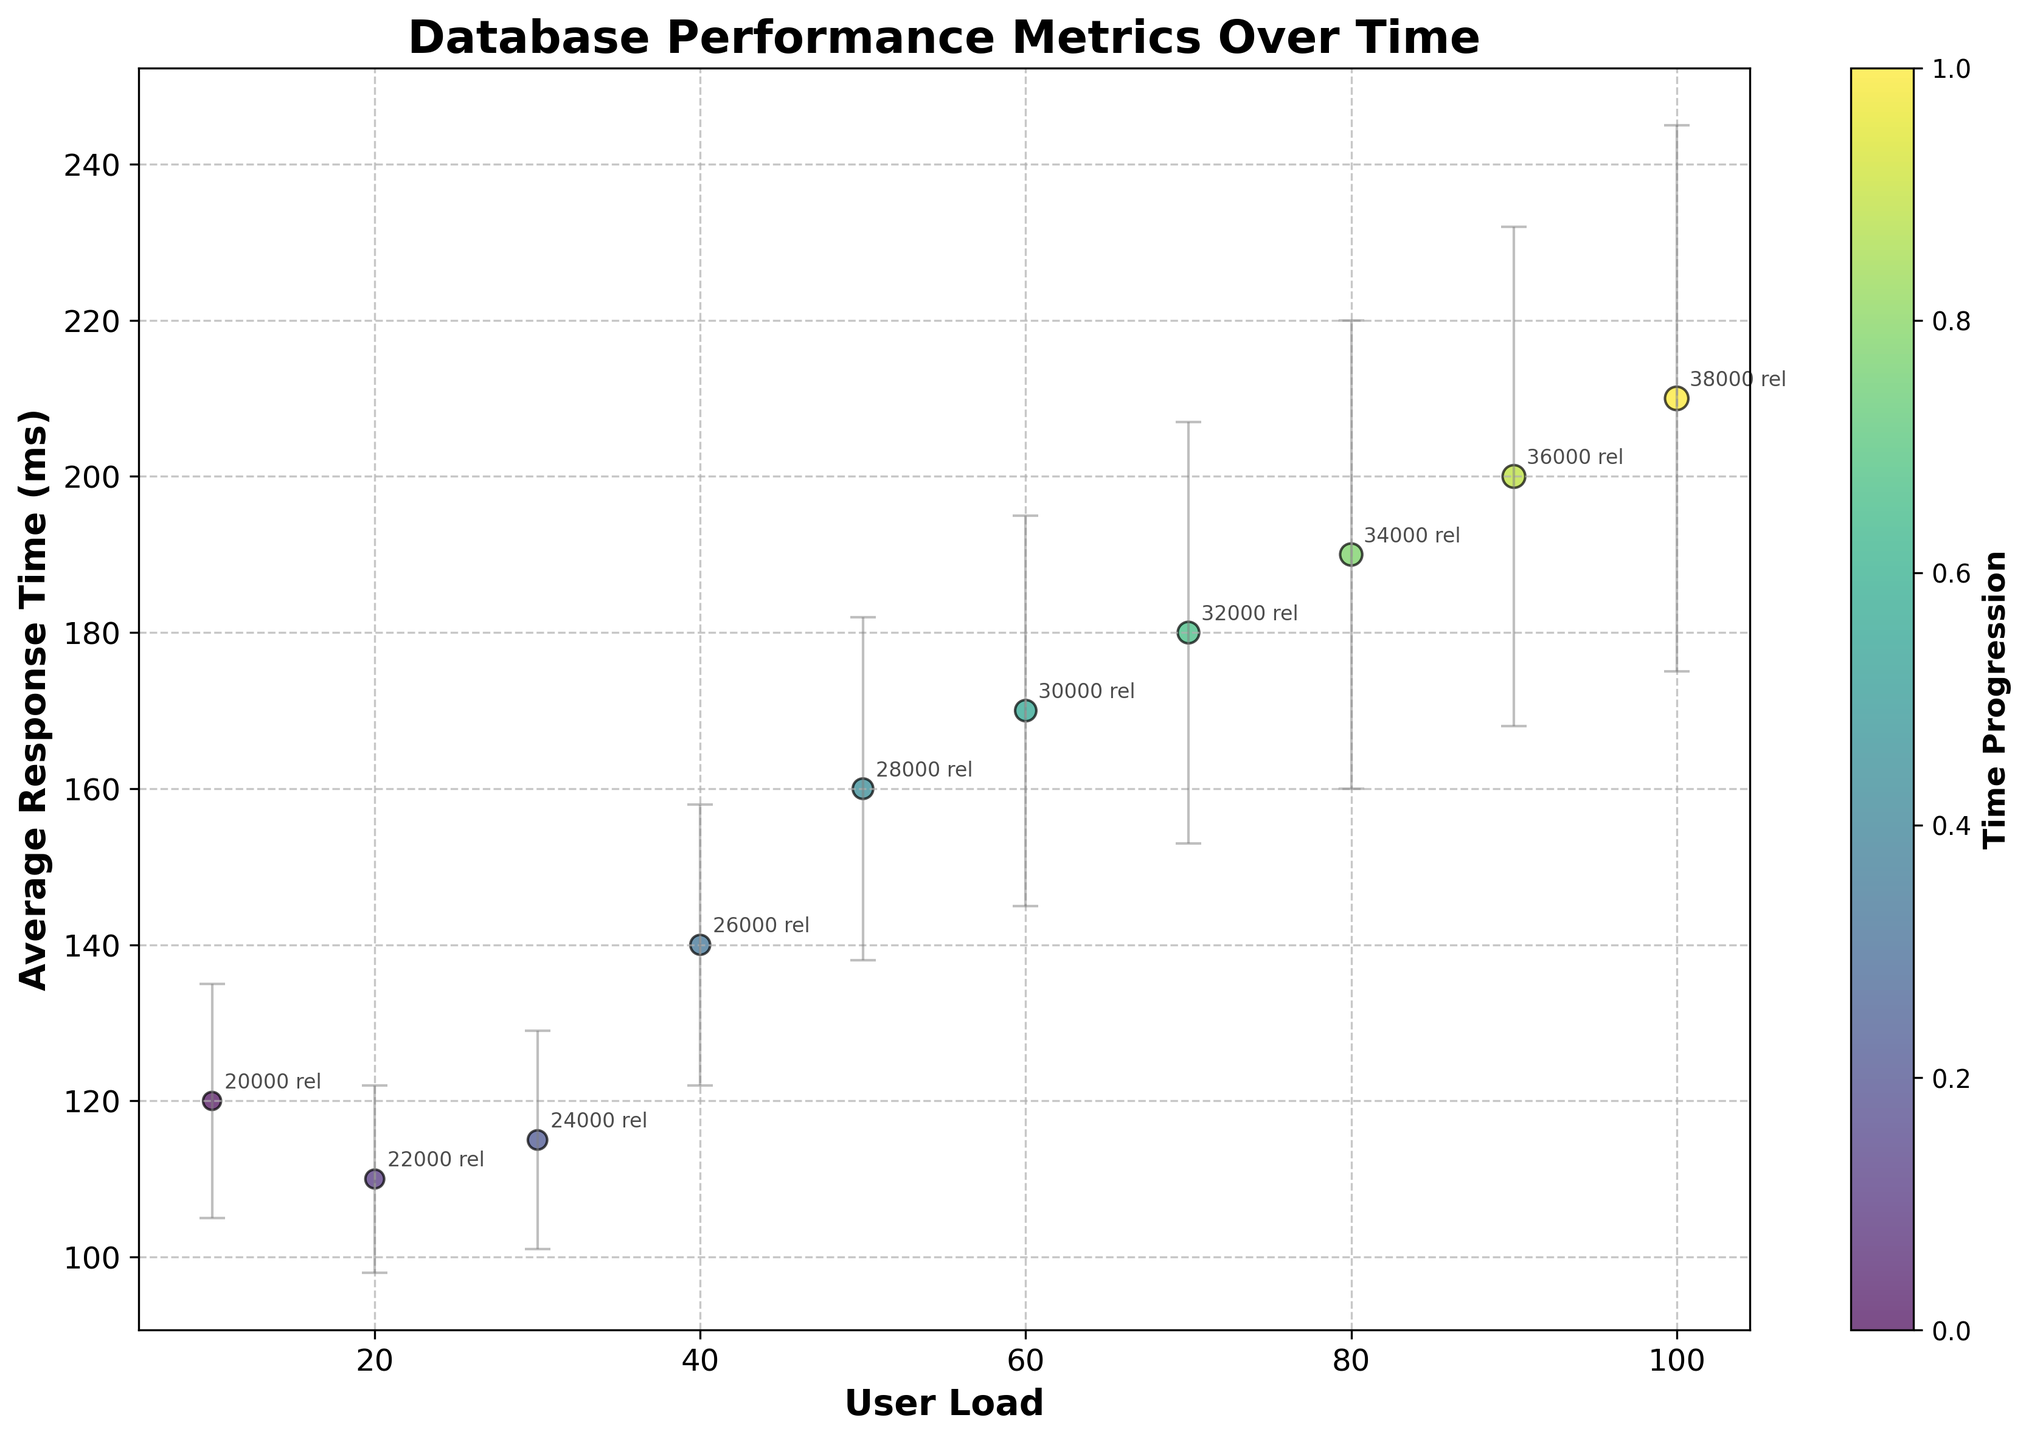How many data points are shown in the scatter plot? Count the number of scatter points on the plot. Each point corresponds to a time entry.
Answer: 10 What are the labels of the x-axis and y-axis? Check the text next to the x-axis and y-axis for their respective labels.
Answer: User Load, Average Response Time (ms) What is the highest average response time recorded, and at what user load does it occur? Identify the topmost point on the plot and find its corresponding x and y values. The highest point represents the highest average response time.
Answer: 210 ms at 100 user load Which data point has the smallest bubble size, and what is its user load? Locate the smallest bubble on the scatter plot. Bubble size represents the number of nodes. Find the corresponding user load for this point.
Answer: 10 user load How does the average response time change with increasing user load? Observe the trend in the scatter plot as the user load increases along the x-axis. Note if the average response time generally goes up or down.
Answer: It increases What is the difference in average response time between the user loads of 40 and 60? Find the average response times at 40 and 60 user loads from the scatter plot and subtract one from the other.
Answer: 30 ms Which data point has the largest error bar, and what is its user load? Identify the point with the longest vertical error bar and note its corresponding user load.
Answer: 100 user load At which user load does the average response time cross 150 ms? Find the point where the average response time goes above 150 ms on the y-axis and note its corresponding user load.
Answer: 50 user load How does the scatter's color gradient represent time progression? Observe the scatter plot's color gradient and its correspondence to time progression shown by the color bar legend.
Answer: Time progresses from lighter to darker colors What is the relationship count for the user load of 20, and how can it be identified? Locate the point for user load 20 on the x-axis, and check the annotated text nearby indicating the relationship count.
Answer: 22000 relationships 